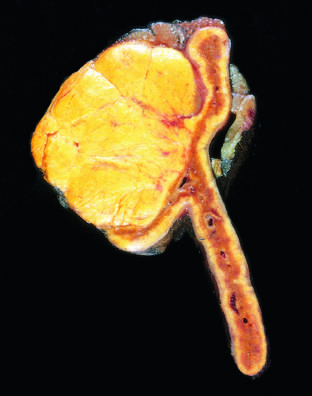the adenoma is distinguished from nodular hyperplasia by whose solitary , circumscribed nature?
Answer the question using a single word or phrase. Its 